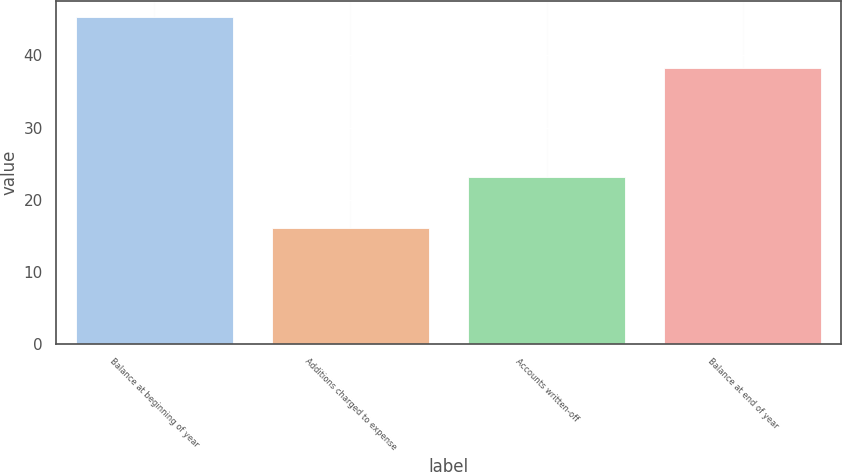Convert chart. <chart><loc_0><loc_0><loc_500><loc_500><bar_chart><fcel>Balance at beginning of year<fcel>Additions charged to expense<fcel>Accounts written-off<fcel>Balance at end of year<nl><fcel>45.3<fcel>16.1<fcel>23.1<fcel>38.3<nl></chart> 